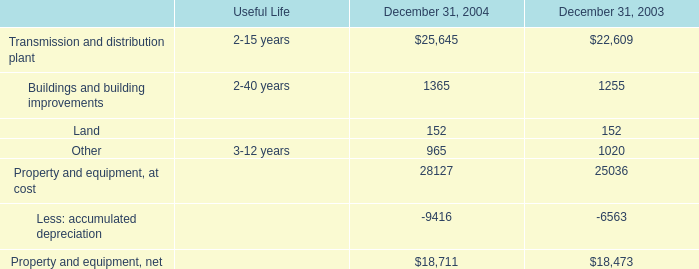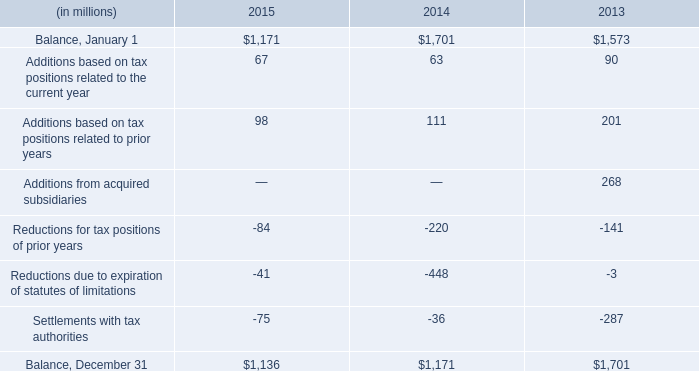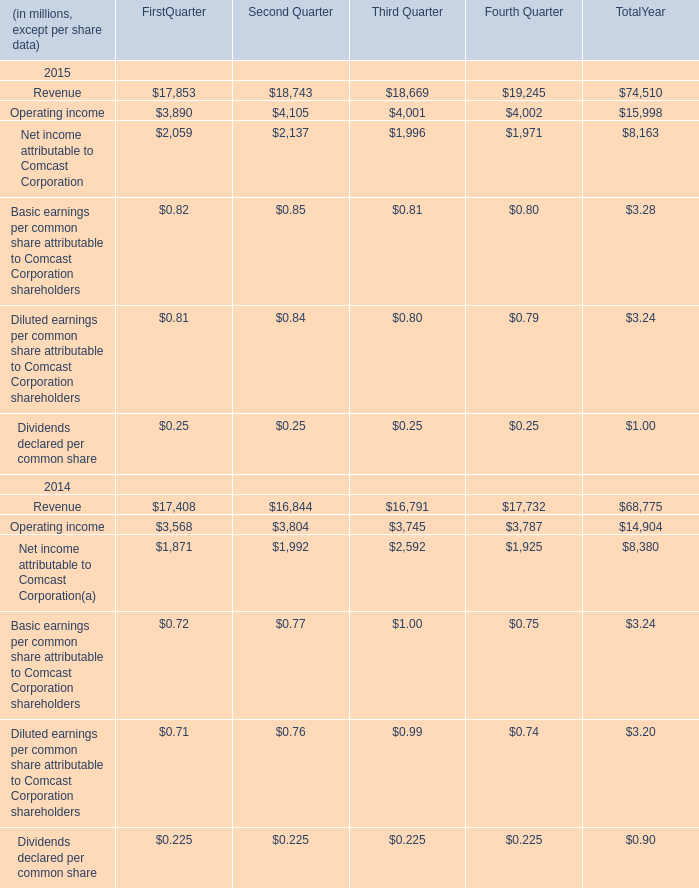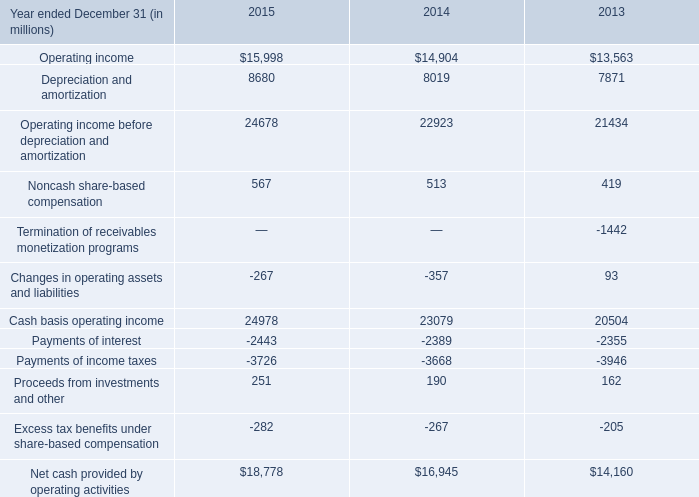What is the average value of Depreciation and amortization and Revenue for FirstQuarter in 2015? (in million) 
Computations: ((17853 + 8680) / 2)
Answer: 13266.5. 